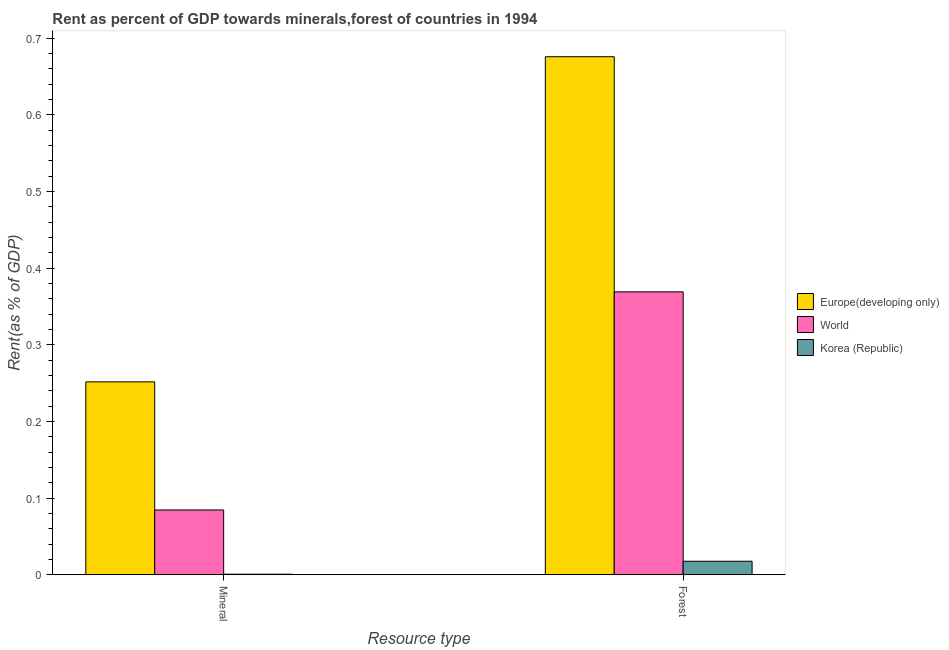How many different coloured bars are there?
Ensure brevity in your answer.  3. Are the number of bars on each tick of the X-axis equal?
Ensure brevity in your answer.  Yes. How many bars are there on the 1st tick from the right?
Your response must be concise. 3. What is the label of the 1st group of bars from the left?
Offer a very short reply. Mineral. What is the mineral rent in Europe(developing only)?
Ensure brevity in your answer.  0.25. Across all countries, what is the maximum mineral rent?
Give a very brief answer. 0.25. Across all countries, what is the minimum forest rent?
Ensure brevity in your answer.  0.02. In which country was the mineral rent maximum?
Your answer should be very brief. Europe(developing only). What is the total mineral rent in the graph?
Keep it short and to the point. 0.34. What is the difference between the mineral rent in Europe(developing only) and that in World?
Your answer should be very brief. 0.17. What is the difference between the mineral rent in Korea (Republic) and the forest rent in World?
Give a very brief answer. -0.37. What is the average forest rent per country?
Give a very brief answer. 0.35. What is the difference between the forest rent and mineral rent in Korea (Republic)?
Give a very brief answer. 0.02. What is the ratio of the forest rent in Europe(developing only) to that in World?
Make the answer very short. 1.83. Is the forest rent in Korea (Republic) less than that in Europe(developing only)?
Your answer should be compact. Yes. What does the 1st bar from the left in Mineral represents?
Offer a very short reply. Europe(developing only). How many bars are there?
Your response must be concise. 6. How many countries are there in the graph?
Your response must be concise. 3. What is the difference between two consecutive major ticks on the Y-axis?
Provide a succinct answer. 0.1. How many legend labels are there?
Give a very brief answer. 3. How are the legend labels stacked?
Make the answer very short. Vertical. What is the title of the graph?
Provide a succinct answer. Rent as percent of GDP towards minerals,forest of countries in 1994. What is the label or title of the X-axis?
Provide a succinct answer. Resource type. What is the label or title of the Y-axis?
Your answer should be compact. Rent(as % of GDP). What is the Rent(as % of GDP) of Europe(developing only) in Mineral?
Keep it short and to the point. 0.25. What is the Rent(as % of GDP) in World in Mineral?
Provide a short and direct response. 0.08. What is the Rent(as % of GDP) in Korea (Republic) in Mineral?
Provide a short and direct response. 0. What is the Rent(as % of GDP) in Europe(developing only) in Forest?
Offer a terse response. 0.68. What is the Rent(as % of GDP) of World in Forest?
Your answer should be very brief. 0.37. What is the Rent(as % of GDP) of Korea (Republic) in Forest?
Provide a succinct answer. 0.02. Across all Resource type, what is the maximum Rent(as % of GDP) in Europe(developing only)?
Offer a terse response. 0.68. Across all Resource type, what is the maximum Rent(as % of GDP) of World?
Give a very brief answer. 0.37. Across all Resource type, what is the maximum Rent(as % of GDP) of Korea (Republic)?
Your response must be concise. 0.02. Across all Resource type, what is the minimum Rent(as % of GDP) of Europe(developing only)?
Your answer should be compact. 0.25. Across all Resource type, what is the minimum Rent(as % of GDP) in World?
Your answer should be compact. 0.08. Across all Resource type, what is the minimum Rent(as % of GDP) in Korea (Republic)?
Ensure brevity in your answer.  0. What is the total Rent(as % of GDP) in Europe(developing only) in the graph?
Offer a terse response. 0.93. What is the total Rent(as % of GDP) of World in the graph?
Offer a terse response. 0.45. What is the total Rent(as % of GDP) of Korea (Republic) in the graph?
Provide a succinct answer. 0.02. What is the difference between the Rent(as % of GDP) of Europe(developing only) in Mineral and that in Forest?
Your response must be concise. -0.42. What is the difference between the Rent(as % of GDP) in World in Mineral and that in Forest?
Offer a terse response. -0.28. What is the difference between the Rent(as % of GDP) in Korea (Republic) in Mineral and that in Forest?
Keep it short and to the point. -0.02. What is the difference between the Rent(as % of GDP) in Europe(developing only) in Mineral and the Rent(as % of GDP) in World in Forest?
Your answer should be compact. -0.12. What is the difference between the Rent(as % of GDP) of Europe(developing only) in Mineral and the Rent(as % of GDP) of Korea (Republic) in Forest?
Offer a terse response. 0.23. What is the difference between the Rent(as % of GDP) of World in Mineral and the Rent(as % of GDP) of Korea (Republic) in Forest?
Make the answer very short. 0.07. What is the average Rent(as % of GDP) of Europe(developing only) per Resource type?
Your answer should be compact. 0.46. What is the average Rent(as % of GDP) of World per Resource type?
Offer a terse response. 0.23. What is the average Rent(as % of GDP) in Korea (Republic) per Resource type?
Offer a very short reply. 0.01. What is the difference between the Rent(as % of GDP) of Europe(developing only) and Rent(as % of GDP) of World in Mineral?
Offer a terse response. 0.17. What is the difference between the Rent(as % of GDP) in Europe(developing only) and Rent(as % of GDP) in Korea (Republic) in Mineral?
Provide a short and direct response. 0.25. What is the difference between the Rent(as % of GDP) of World and Rent(as % of GDP) of Korea (Republic) in Mineral?
Your answer should be compact. 0.08. What is the difference between the Rent(as % of GDP) in Europe(developing only) and Rent(as % of GDP) in World in Forest?
Your response must be concise. 0.31. What is the difference between the Rent(as % of GDP) of Europe(developing only) and Rent(as % of GDP) of Korea (Republic) in Forest?
Provide a succinct answer. 0.66. What is the difference between the Rent(as % of GDP) in World and Rent(as % of GDP) in Korea (Republic) in Forest?
Your answer should be very brief. 0.35. What is the ratio of the Rent(as % of GDP) in Europe(developing only) in Mineral to that in Forest?
Give a very brief answer. 0.37. What is the ratio of the Rent(as % of GDP) of World in Mineral to that in Forest?
Provide a succinct answer. 0.23. What is the ratio of the Rent(as % of GDP) of Korea (Republic) in Mineral to that in Forest?
Provide a short and direct response. 0.04. What is the difference between the highest and the second highest Rent(as % of GDP) in Europe(developing only)?
Your response must be concise. 0.42. What is the difference between the highest and the second highest Rent(as % of GDP) of World?
Ensure brevity in your answer.  0.28. What is the difference between the highest and the second highest Rent(as % of GDP) in Korea (Republic)?
Your answer should be compact. 0.02. What is the difference between the highest and the lowest Rent(as % of GDP) of Europe(developing only)?
Give a very brief answer. 0.42. What is the difference between the highest and the lowest Rent(as % of GDP) in World?
Make the answer very short. 0.28. What is the difference between the highest and the lowest Rent(as % of GDP) in Korea (Republic)?
Your answer should be very brief. 0.02. 